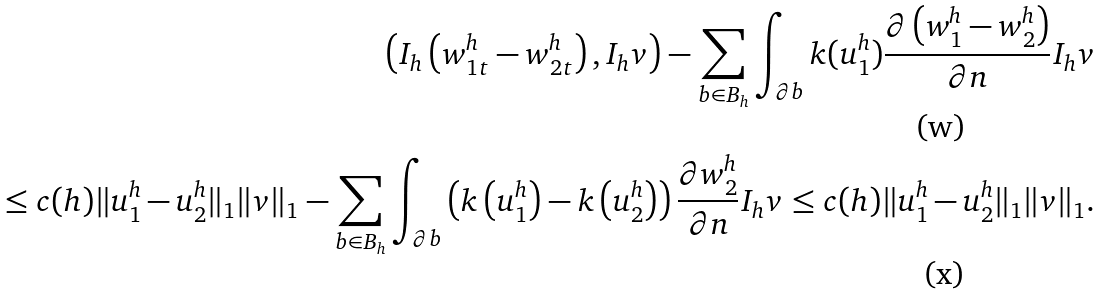<formula> <loc_0><loc_0><loc_500><loc_500>\left ( I _ { h } \left ( w _ { 1 t } ^ { h } - w _ { 2 t } ^ { h } \right ) , I _ { h } v \right ) - \sum _ { b \in B _ { h } } \int _ { \partial b } k ( u ^ { h } _ { 1 } ) \frac { \partial \left ( w ^ { h } _ { 1 } - w ^ { h } _ { 2 } \right ) } { \partial n } I _ { h } v \\ \leq c ( h ) \| u _ { 1 } ^ { h } - u _ { 2 } ^ { h } \| _ { 1 } \| v \| _ { 1 } - \sum _ { b \in B _ { h } } \int _ { \partial b } \left ( k \left ( u ^ { h } _ { 1 } \right ) - k \left ( u ^ { h } _ { 2 } \right ) \right ) \frac { \partial w ^ { h } _ { 2 } } { \partial n } I _ { h } v \leq c ( h ) \| u _ { 1 } ^ { h } - u _ { 2 } ^ { h } \| _ { 1 } \| v \| _ { 1 } .</formula> 